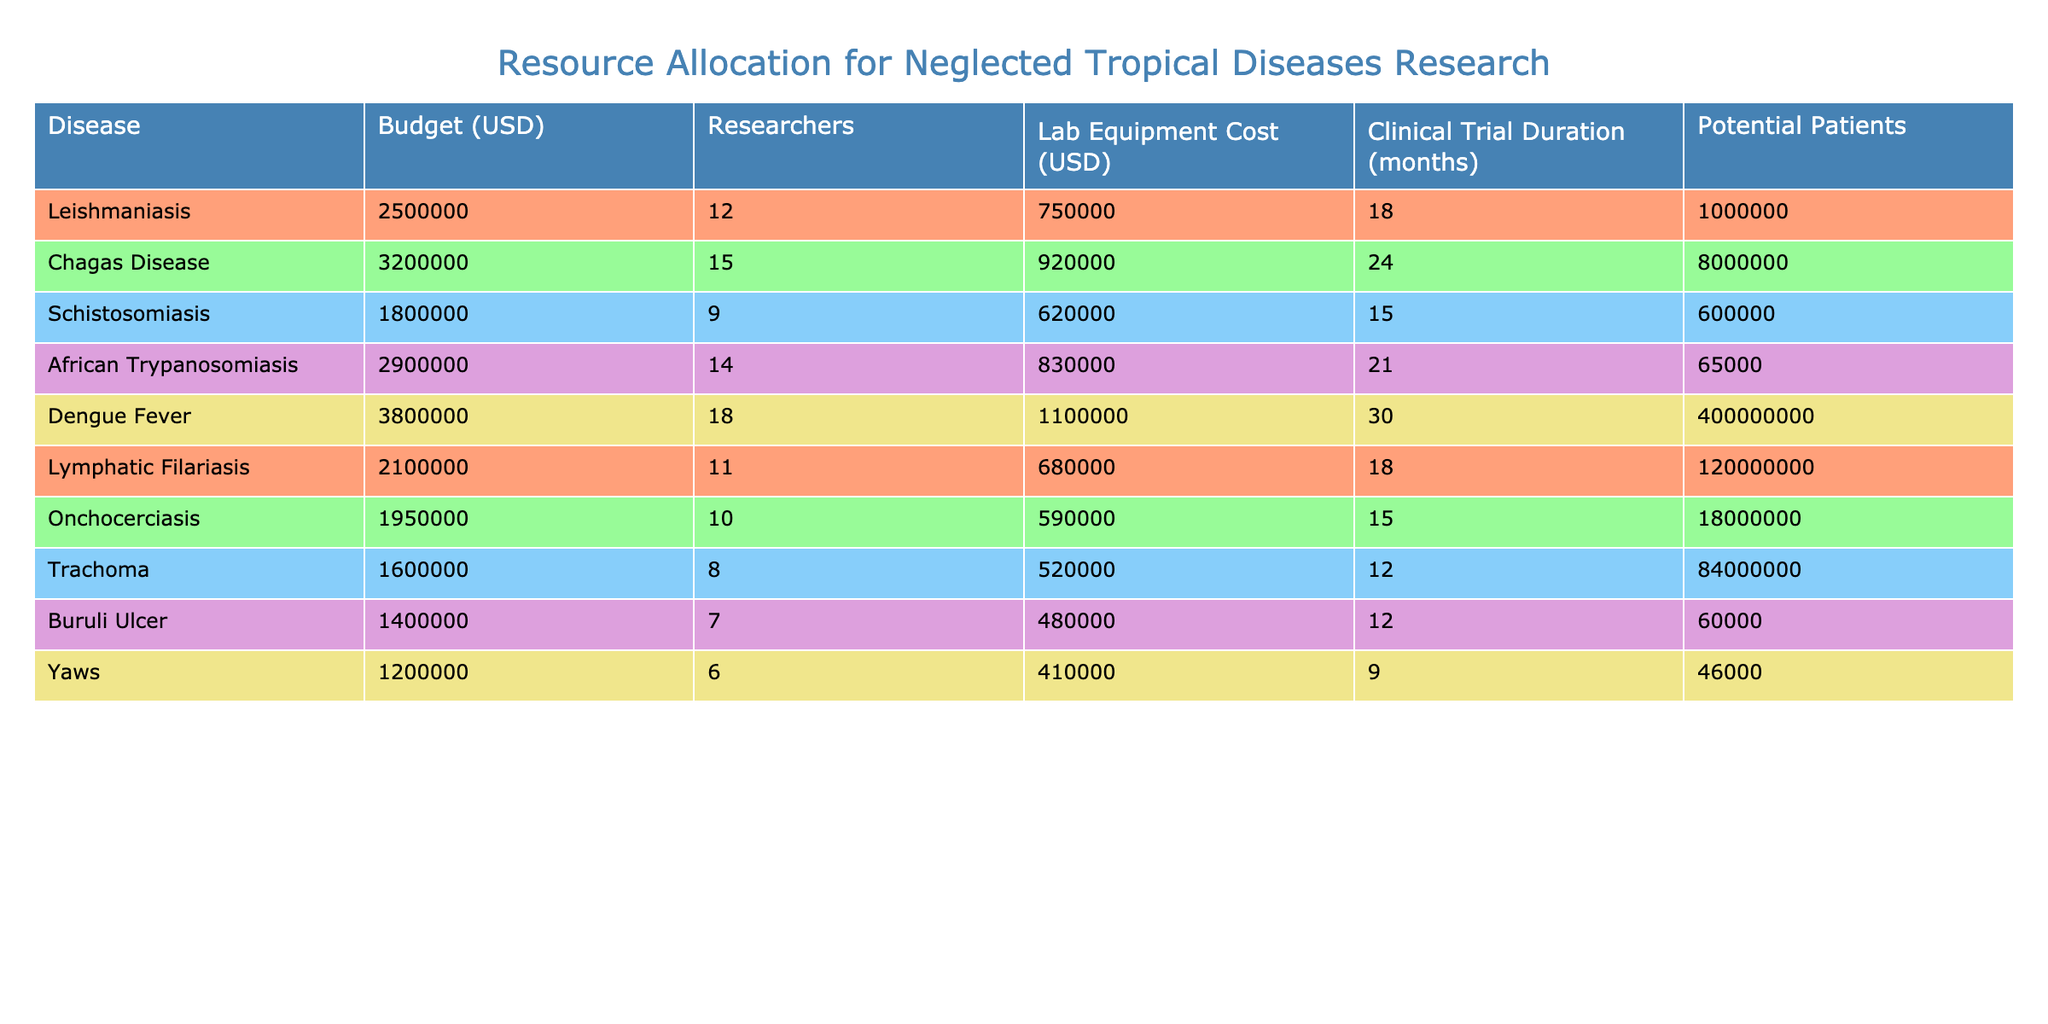What is the budget allocated for Leishmaniasis research? The table lists the budget for Leishmaniasis as $2,500,000.
Answer: 2,500,000 How many researchers are assigned to Chagas Disease? According to the table, Chagas Disease has 15 researchers assigned to it.
Answer: 15 What is the clinical trial duration for Dengue Fever? The table indicates that the clinical trial duration for Dengue Fever is 30 months.
Answer: 30 months Which disease has the highest number of potential patients? Looking at the potential patients column, Dengue Fever has the highest number at 400,000,000.
Answer: Dengue Fever What is the total budget for Schistosomiasis and Yaws? The total budget is calculated by adding the budgets for Schistosomiasis ($1,800,000) and Yaws ($1,200,000), yielding $3,000,000.
Answer: 3,000,000 Is the lab equipment cost for Onchocerciasis more than for Buruli Ulcer? The lab equipment cost for Onchocerciasis is $590,000, while for Buruli Ulcer it is $480,000, which means Onchocerciasis has a higher cost.
Answer: Yes What is the average budget allocated across all diseases? The average budget is calculated by summing all the budgets: $25,000,000, and dividing by the number of diseases (10), which gives an average budget of $2,500,000.
Answer: 2,500,000 Which disease has the lowest clinical trial duration? By comparing the clinical trial durations listed, Yaws has the lowest duration at 9 months.
Answer: Yaws How much more is the lab equipment cost for Chagas Disease compared to African Trypanosomiasis? The lab equipment cost for Chagas Disease is $920,000, and for African Trypanosomiasis, it is $830,000. The difference is $920,000 - $830,000 = $90,000.
Answer: 90,000 How many researchers are involved in all projects combined? The total number of researchers is the sum of researchers across all diseases: 12 + 15 + 9 + 14 + 18 + 11 + 10 + 8 + 7 + 6 = 120.
Answer: 120 